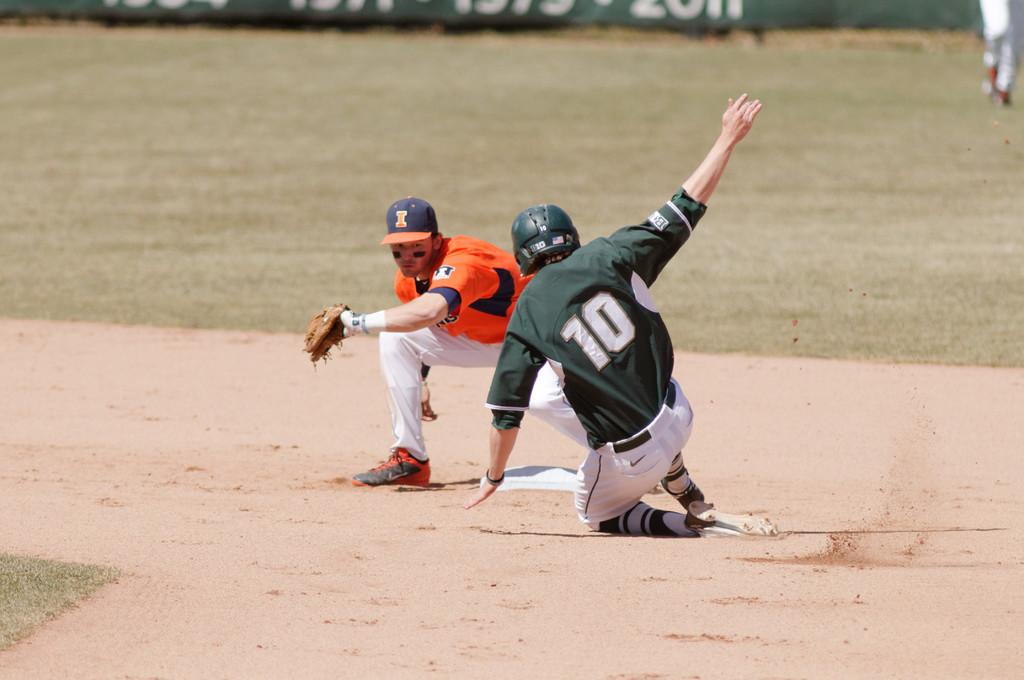<image>
Summarize the visual content of the image. a man in 10 jersey slides toward a base while another player tries to get him out 